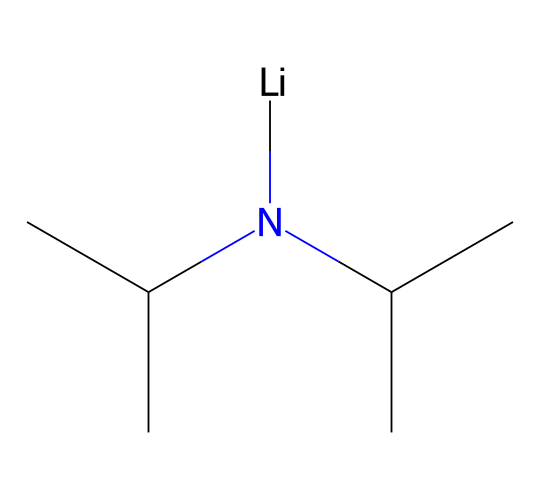What is the main functional group present in lithium diisopropylamide? The SMILES representation indicates the presence of a nitrogen atom bonded to carbon chains. This nitrogen atom characterizes it as an amide.
Answer: amide How many isopropyl groups are present in the structure? The chemical structure includes two isopropyl groups, each represented by the sequence "C(C)C" in the SMILES.
Answer: two What is the central atom in lithium diisopropylamide? The "Li" in the SMILES structure signifies lithium as the central atom.
Answer: lithium What type of bonding is seen between lithium and nitrogen? Based on the presence of "Li" directly connected to "N," this indicates an ionic interaction, characteristic of metal-nonmetal bonding.
Answer: ionic Is lithium diisopropylamide considered a superbase? The nitrogen's properties, combined with the bulky isopropyl groups, give it a high basicity, confirming its classification as a superbase.
Answer: yes What is the total number of carbon atoms in lithium diisopropylamide? By counting the carbon atoms in the isopropyl groups (two groups of three carbon atoms each), the total comes to six carbon atoms in the compound.
Answer: six 